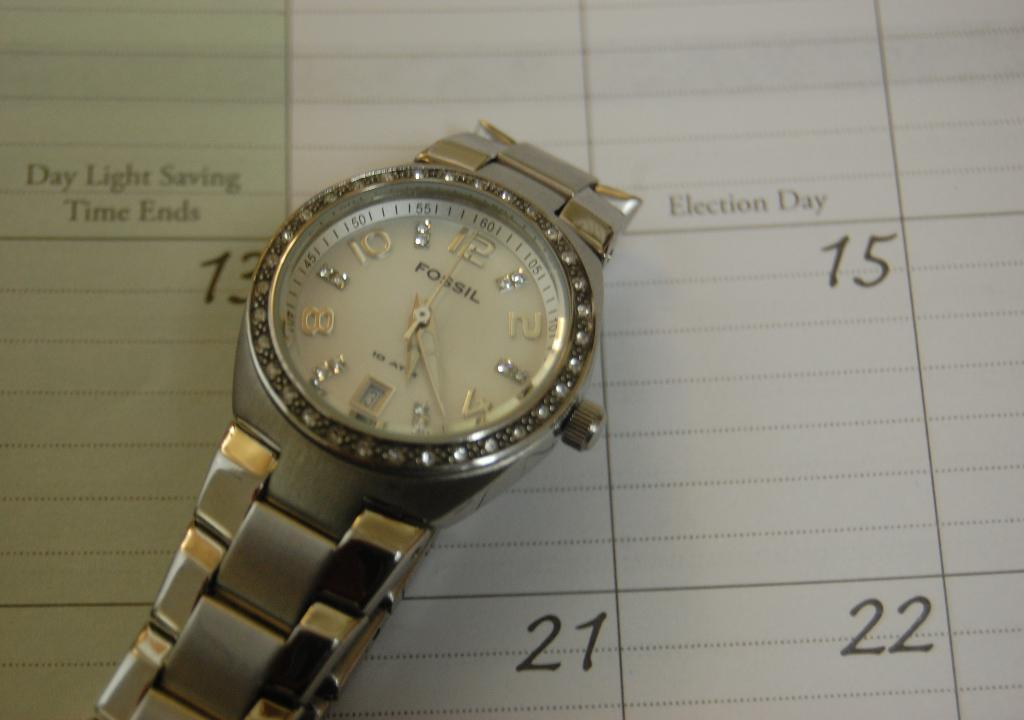<image>
Write a terse but informative summary of the picture. A silver and gold Fossil watch with crystals surrounding the dial lying on a a calendar 